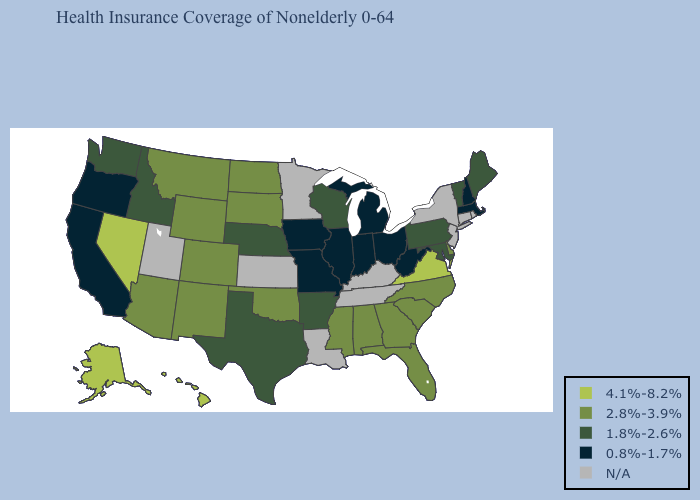Name the states that have a value in the range 2.8%-3.9%?
Concise answer only. Alabama, Arizona, Colorado, Delaware, Florida, Georgia, Mississippi, Montana, New Mexico, North Carolina, North Dakota, Oklahoma, South Carolina, South Dakota, Wyoming. Among the states that border Tennessee , which have the highest value?
Quick response, please. Virginia. Name the states that have a value in the range 4.1%-8.2%?
Short answer required. Alaska, Hawaii, Nevada, Virginia. What is the value of Ohio?
Write a very short answer. 0.8%-1.7%. What is the value of Delaware?
Keep it brief. 2.8%-3.9%. Among the states that border South Carolina , which have the highest value?
Keep it brief. Georgia, North Carolina. Name the states that have a value in the range 1.8%-2.6%?
Be succinct. Arkansas, Idaho, Maine, Maryland, Nebraska, Pennsylvania, Texas, Vermont, Washington, Wisconsin. What is the value of West Virginia?
Give a very brief answer. 0.8%-1.7%. Which states hav the highest value in the South?
Short answer required. Virginia. What is the value of Connecticut?
Give a very brief answer. N/A. Name the states that have a value in the range N/A?
Quick response, please. Connecticut, Kansas, Kentucky, Louisiana, Minnesota, New Jersey, New York, Rhode Island, Tennessee, Utah. What is the value of Alabama?
Quick response, please. 2.8%-3.9%. Name the states that have a value in the range N/A?
Short answer required. Connecticut, Kansas, Kentucky, Louisiana, Minnesota, New Jersey, New York, Rhode Island, Tennessee, Utah. Which states have the lowest value in the South?
Give a very brief answer. West Virginia. 